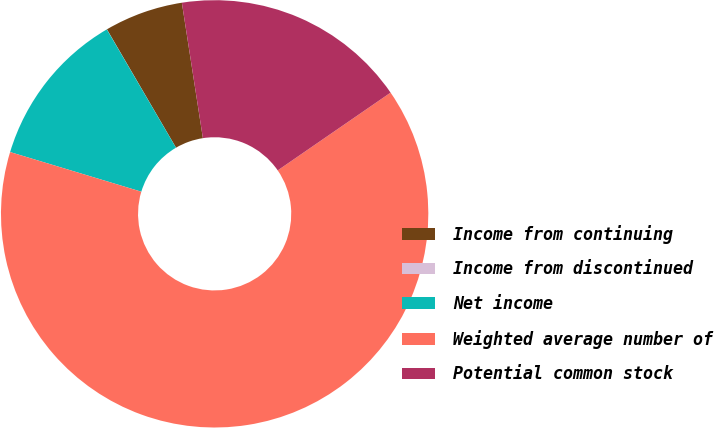Convert chart. <chart><loc_0><loc_0><loc_500><loc_500><pie_chart><fcel>Income from continuing<fcel>Income from discontinued<fcel>Net income<fcel>Weighted average number of<fcel>Potential common stock<nl><fcel>5.96%<fcel>0.01%<fcel>11.91%<fcel>64.27%<fcel>17.85%<nl></chart> 